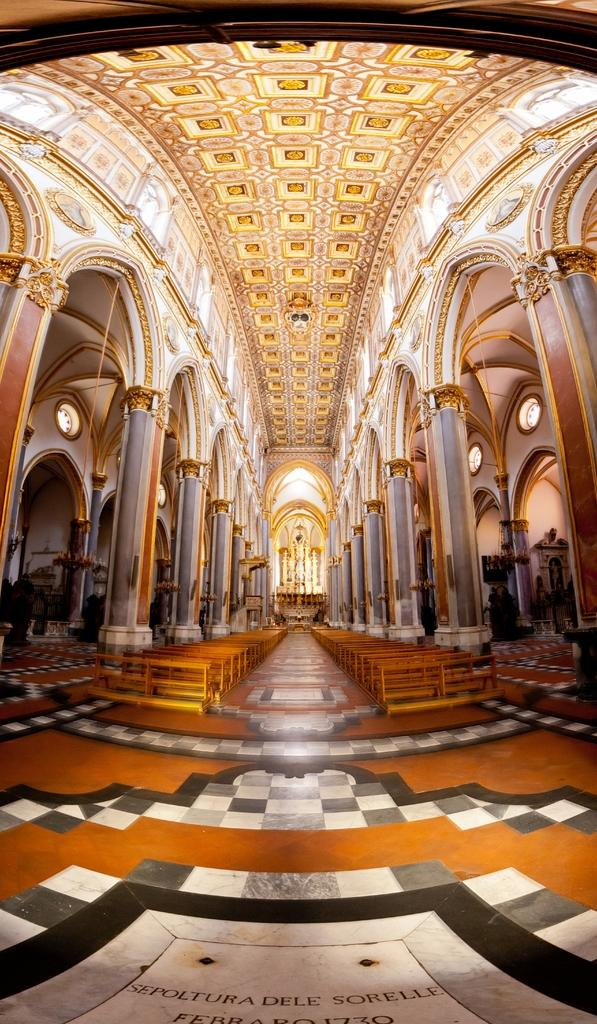Where is the image taken? The image is inside a building. What architectural features can be seen in the image? There are pillars in the image. What type of furniture is present in the image? There are benches in the image. What type of grape is being used in the story depicted in the image? There is no story or grape present in the image; it only shows pillars and benches inside a building. 